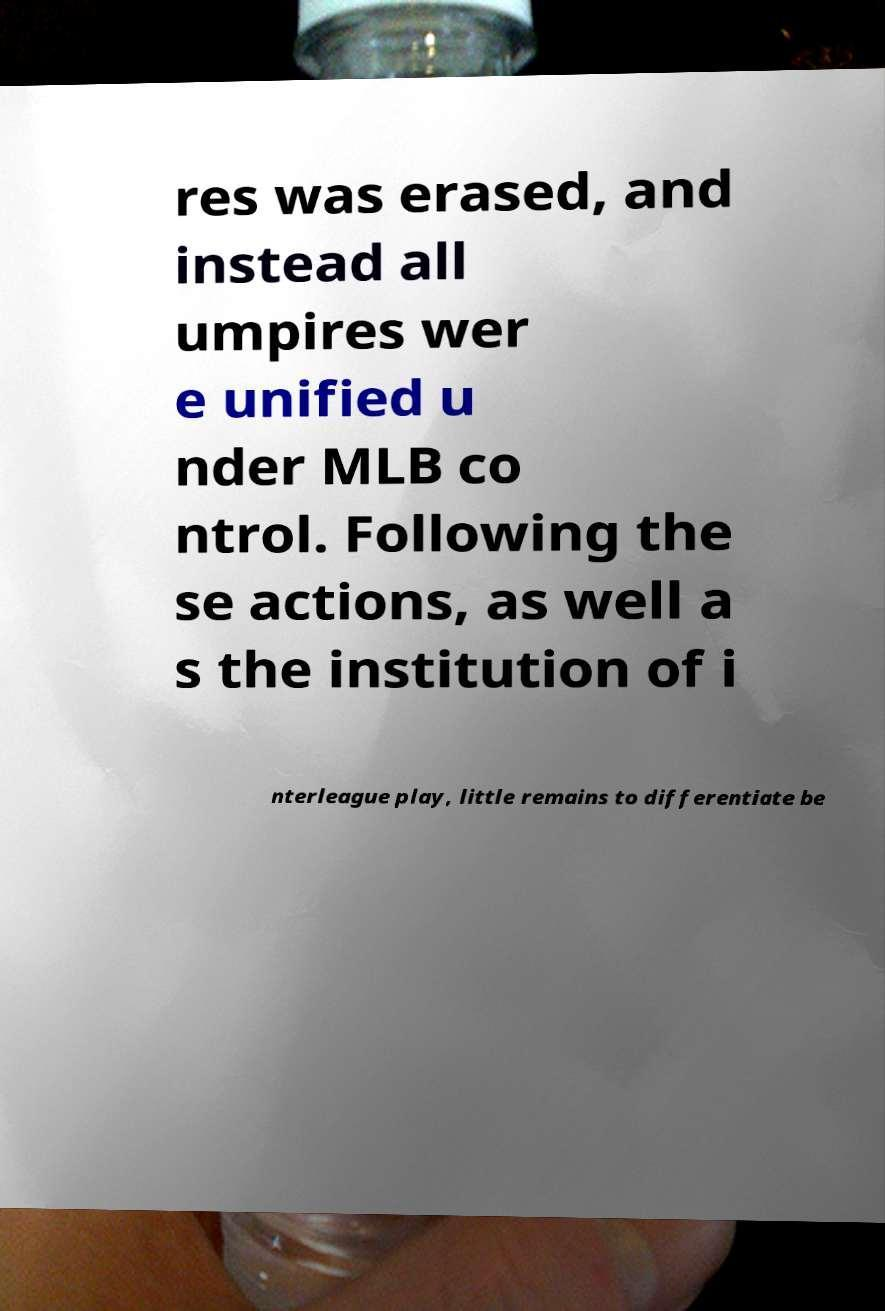Please identify and transcribe the text found in this image. res was erased, and instead all umpires wer e unified u nder MLB co ntrol. Following the se actions, as well a s the institution of i nterleague play, little remains to differentiate be 